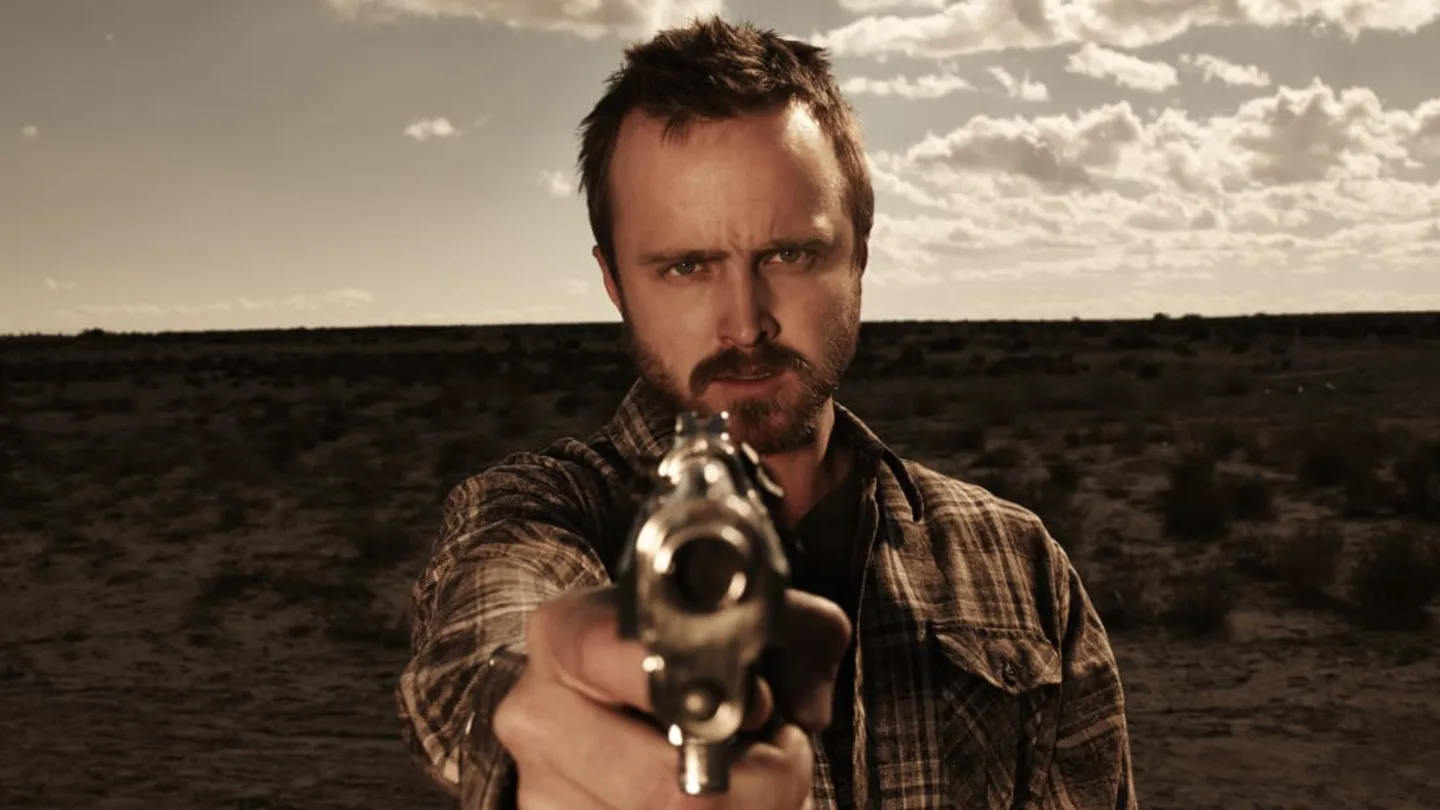Describe the emotions conveyed by the person in this photo. The person in the photo conveys a mixture of intensity, determination, and perhaps a hint of aggression. His direct gaze and the tight grip on his gun indicate a readiness to confront whatever threat he faces. The set of his jaw and furrowing of his brows reflect a serious and focused state of mind, suggesting he is deeply engaged in a critical, high-stakes situation. 